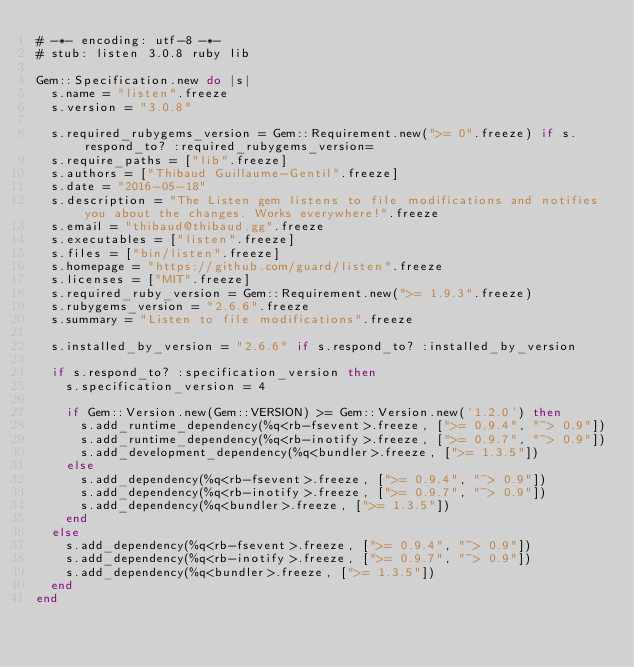<code> <loc_0><loc_0><loc_500><loc_500><_Ruby_># -*- encoding: utf-8 -*-
# stub: listen 3.0.8 ruby lib

Gem::Specification.new do |s|
  s.name = "listen".freeze
  s.version = "3.0.8"

  s.required_rubygems_version = Gem::Requirement.new(">= 0".freeze) if s.respond_to? :required_rubygems_version=
  s.require_paths = ["lib".freeze]
  s.authors = ["Thibaud Guillaume-Gentil".freeze]
  s.date = "2016-05-18"
  s.description = "The Listen gem listens to file modifications and notifies you about the changes. Works everywhere!".freeze
  s.email = "thibaud@thibaud.gg".freeze
  s.executables = ["listen".freeze]
  s.files = ["bin/listen".freeze]
  s.homepage = "https://github.com/guard/listen".freeze
  s.licenses = ["MIT".freeze]
  s.required_ruby_version = Gem::Requirement.new(">= 1.9.3".freeze)
  s.rubygems_version = "2.6.6".freeze
  s.summary = "Listen to file modifications".freeze

  s.installed_by_version = "2.6.6" if s.respond_to? :installed_by_version

  if s.respond_to? :specification_version then
    s.specification_version = 4

    if Gem::Version.new(Gem::VERSION) >= Gem::Version.new('1.2.0') then
      s.add_runtime_dependency(%q<rb-fsevent>.freeze, [">= 0.9.4", "~> 0.9"])
      s.add_runtime_dependency(%q<rb-inotify>.freeze, [">= 0.9.7", "~> 0.9"])
      s.add_development_dependency(%q<bundler>.freeze, [">= 1.3.5"])
    else
      s.add_dependency(%q<rb-fsevent>.freeze, [">= 0.9.4", "~> 0.9"])
      s.add_dependency(%q<rb-inotify>.freeze, [">= 0.9.7", "~> 0.9"])
      s.add_dependency(%q<bundler>.freeze, [">= 1.3.5"])
    end
  else
    s.add_dependency(%q<rb-fsevent>.freeze, [">= 0.9.4", "~> 0.9"])
    s.add_dependency(%q<rb-inotify>.freeze, [">= 0.9.7", "~> 0.9"])
    s.add_dependency(%q<bundler>.freeze, [">= 1.3.5"])
  end
end
</code> 